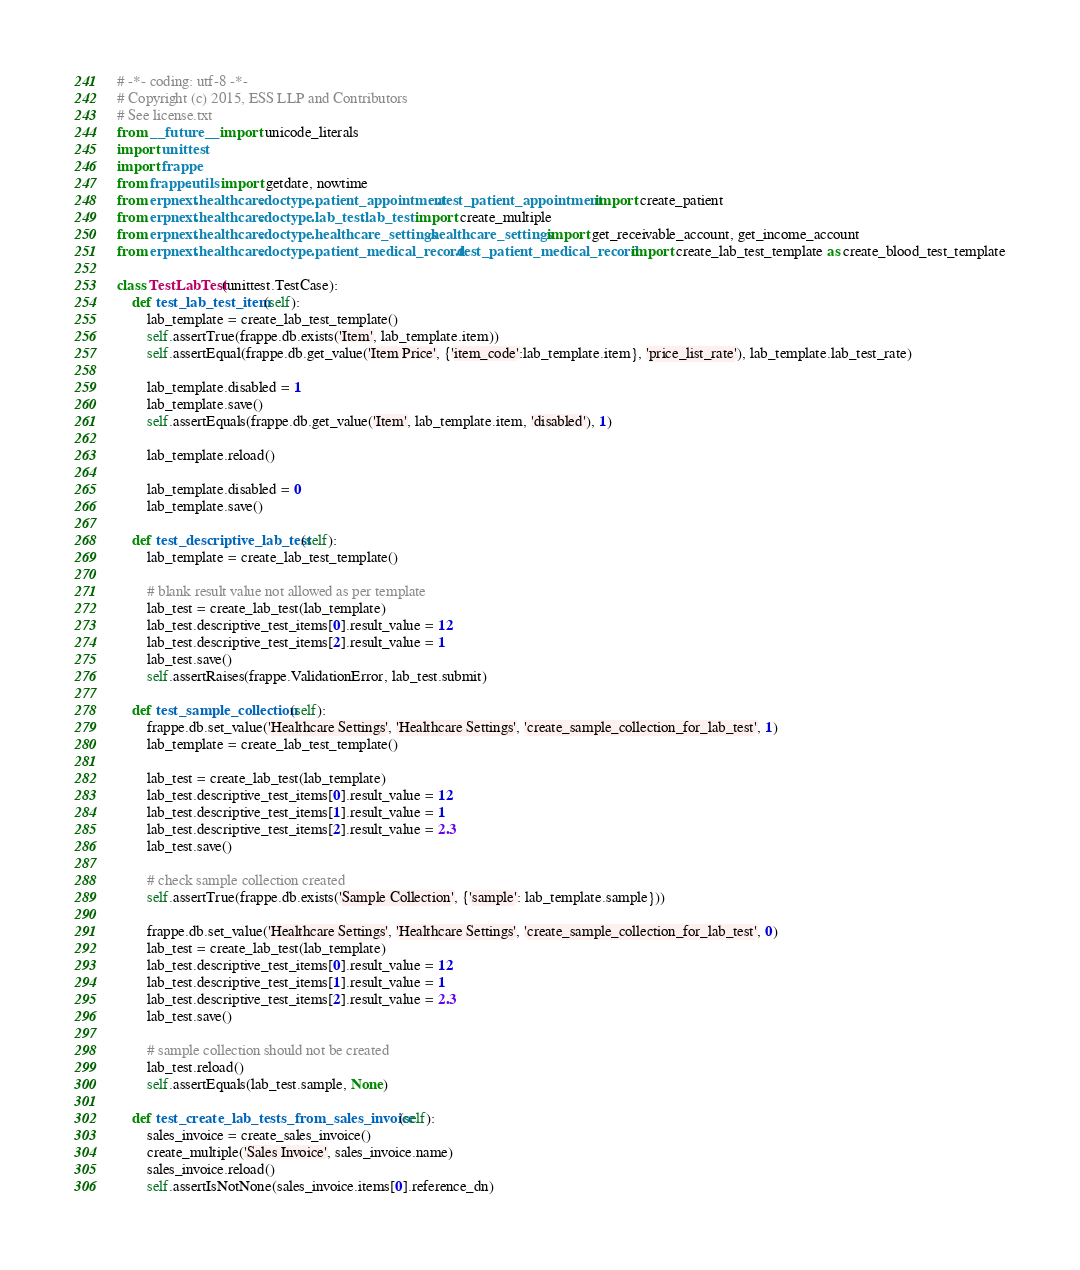<code> <loc_0><loc_0><loc_500><loc_500><_Python_># -*- coding: utf-8 -*-
# Copyright (c) 2015, ESS LLP and Contributors
# See license.txt
from __future__ import unicode_literals
import unittest
import frappe
from frappe.utils import getdate, nowtime
from erpnext.healthcare.doctype.patient_appointment.test_patient_appointment import create_patient
from erpnext.healthcare.doctype.lab_test.lab_test import create_multiple
from erpnext.healthcare.doctype.healthcare_settings.healthcare_settings import get_receivable_account, get_income_account
from erpnext.healthcare.doctype.patient_medical_record.test_patient_medical_record import create_lab_test_template as create_blood_test_template

class TestLabTest(unittest.TestCase):
	def test_lab_test_item(self):
		lab_template = create_lab_test_template()
		self.assertTrue(frappe.db.exists('Item', lab_template.item))
		self.assertEqual(frappe.db.get_value('Item Price', {'item_code':lab_template.item}, 'price_list_rate'), lab_template.lab_test_rate)

		lab_template.disabled = 1
		lab_template.save()
		self.assertEquals(frappe.db.get_value('Item', lab_template.item, 'disabled'), 1)

		lab_template.reload()

		lab_template.disabled = 0
		lab_template.save()

	def test_descriptive_lab_test(self):
		lab_template = create_lab_test_template()

		# blank result value not allowed as per template
		lab_test = create_lab_test(lab_template)
		lab_test.descriptive_test_items[0].result_value = 12
		lab_test.descriptive_test_items[2].result_value = 1
		lab_test.save()
		self.assertRaises(frappe.ValidationError, lab_test.submit)

	def test_sample_collection(self):
		frappe.db.set_value('Healthcare Settings', 'Healthcare Settings', 'create_sample_collection_for_lab_test', 1)
		lab_template = create_lab_test_template()

		lab_test = create_lab_test(lab_template)
		lab_test.descriptive_test_items[0].result_value = 12
		lab_test.descriptive_test_items[1].result_value = 1
		lab_test.descriptive_test_items[2].result_value = 2.3
		lab_test.save()

		# check sample collection created
		self.assertTrue(frappe.db.exists('Sample Collection', {'sample': lab_template.sample}))

		frappe.db.set_value('Healthcare Settings', 'Healthcare Settings', 'create_sample_collection_for_lab_test', 0)
		lab_test = create_lab_test(lab_template)
		lab_test.descriptive_test_items[0].result_value = 12
		lab_test.descriptive_test_items[1].result_value = 1
		lab_test.descriptive_test_items[2].result_value = 2.3
		lab_test.save()

		# sample collection should not be created
		lab_test.reload()
		self.assertEquals(lab_test.sample, None)

	def test_create_lab_tests_from_sales_invoice(self):
		sales_invoice = create_sales_invoice()
		create_multiple('Sales Invoice', sales_invoice.name)
		sales_invoice.reload()
		self.assertIsNotNone(sales_invoice.items[0].reference_dn)</code> 